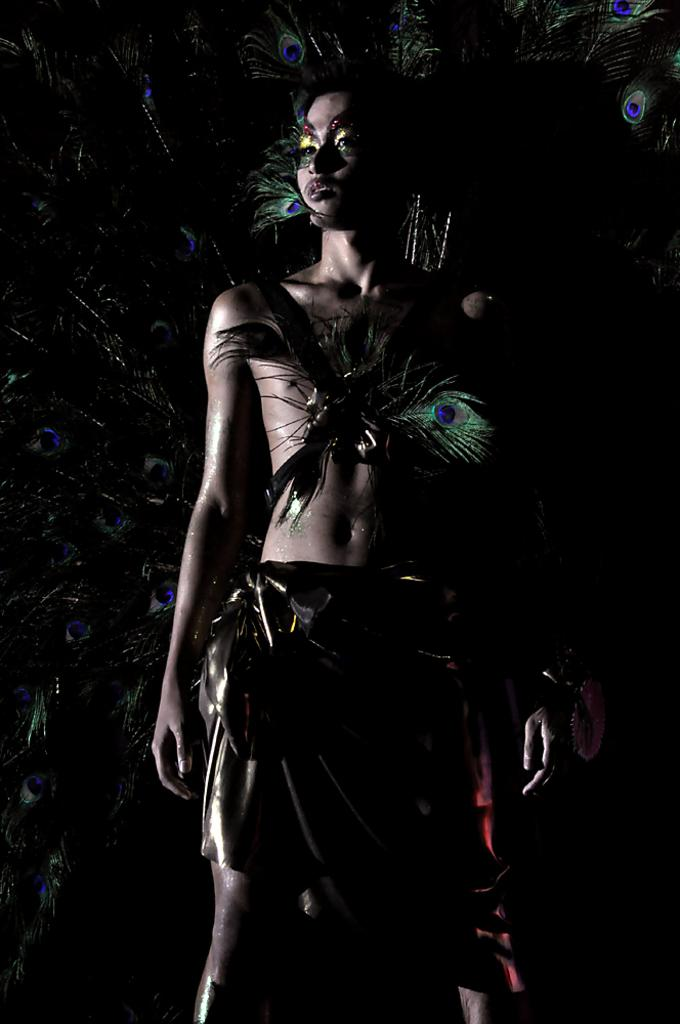What is the main subject of the image? There is a person standing in the image. What can be seen in the background of the image? The background of the image contains feathers of a peacock. What colors are the feathers in the image? The feathers are in blue and green colors. Can you touch the coal in the image? There is no coal present in the image. What direction is the person's head facing in the image? The provided facts do not mention the direction the person's head is facing, so we cannot definitively answer this question. 